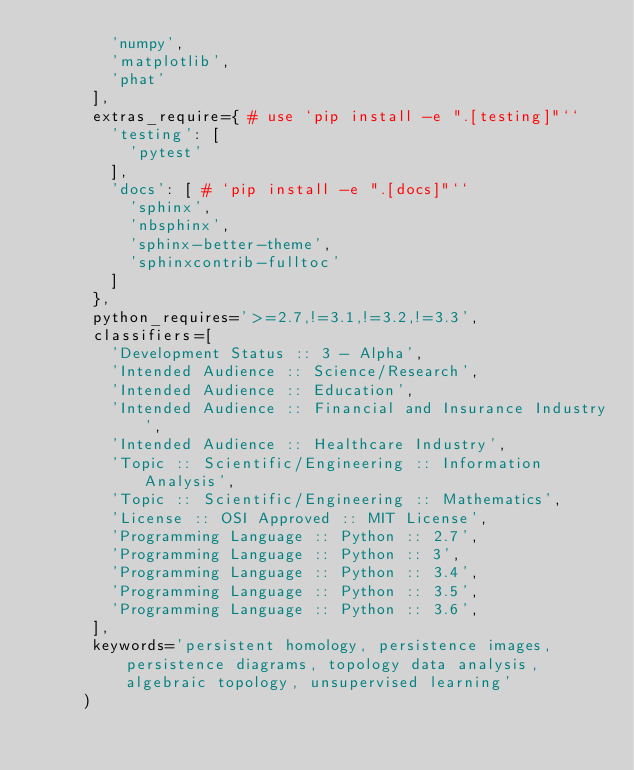Convert code to text. <code><loc_0><loc_0><loc_500><loc_500><_Python_>        'numpy',
        'matplotlib',
        'phat'
      ],
      extras_require={ # use `pip install -e ".[testing]"``
        'testing': [
          'pytest' 
        ],
        'docs': [ # `pip install -e ".[docs]"``
          'sphinx',
          'nbsphinx',
          'sphinx-better-theme',
          'sphinxcontrib-fulltoc'
        ]
      },
      python_requires='>=2.7,!=3.1,!=3.2,!=3.3',
      classifiers=[
        'Development Status :: 3 - Alpha',
        'Intended Audience :: Science/Research',
        'Intended Audience :: Education',
        'Intended Audience :: Financial and Insurance Industry',
        'Intended Audience :: Healthcare Industry',
        'Topic :: Scientific/Engineering :: Information Analysis',
        'Topic :: Scientific/Engineering :: Mathematics',
        'License :: OSI Approved :: MIT License',
        'Programming Language :: Python :: 2.7',
        'Programming Language :: Python :: 3',
        'Programming Language :: Python :: 3.4',
        'Programming Language :: Python :: 3.5',
        'Programming Language :: Python :: 3.6',
      ],
      keywords='persistent homology, persistence images, persistence diagrams, topology data analysis, algebraic topology, unsupervised learning'
     )
</code> 